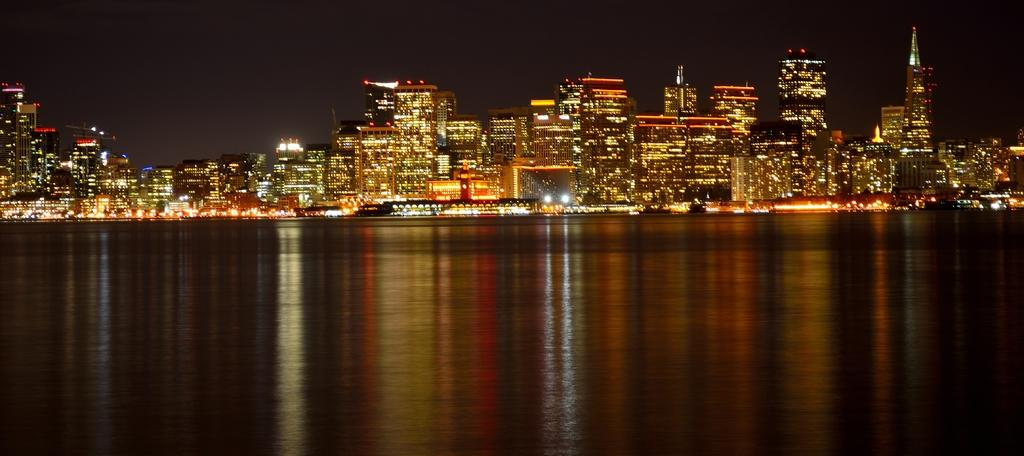What type of natural feature is present in the image? There is a river in the image. What type of man-made structures can be seen in the background of the image? There are buildings in the background of the image. What is visible in the sky in the image? The sky is visible in the background of the image. What month is it in the image? The month cannot be determined from the image, as it does not contain any specific details about the time of year. Can you hear any thunder in the image? There is no auditory information present in the image, as it is a visual medium. 